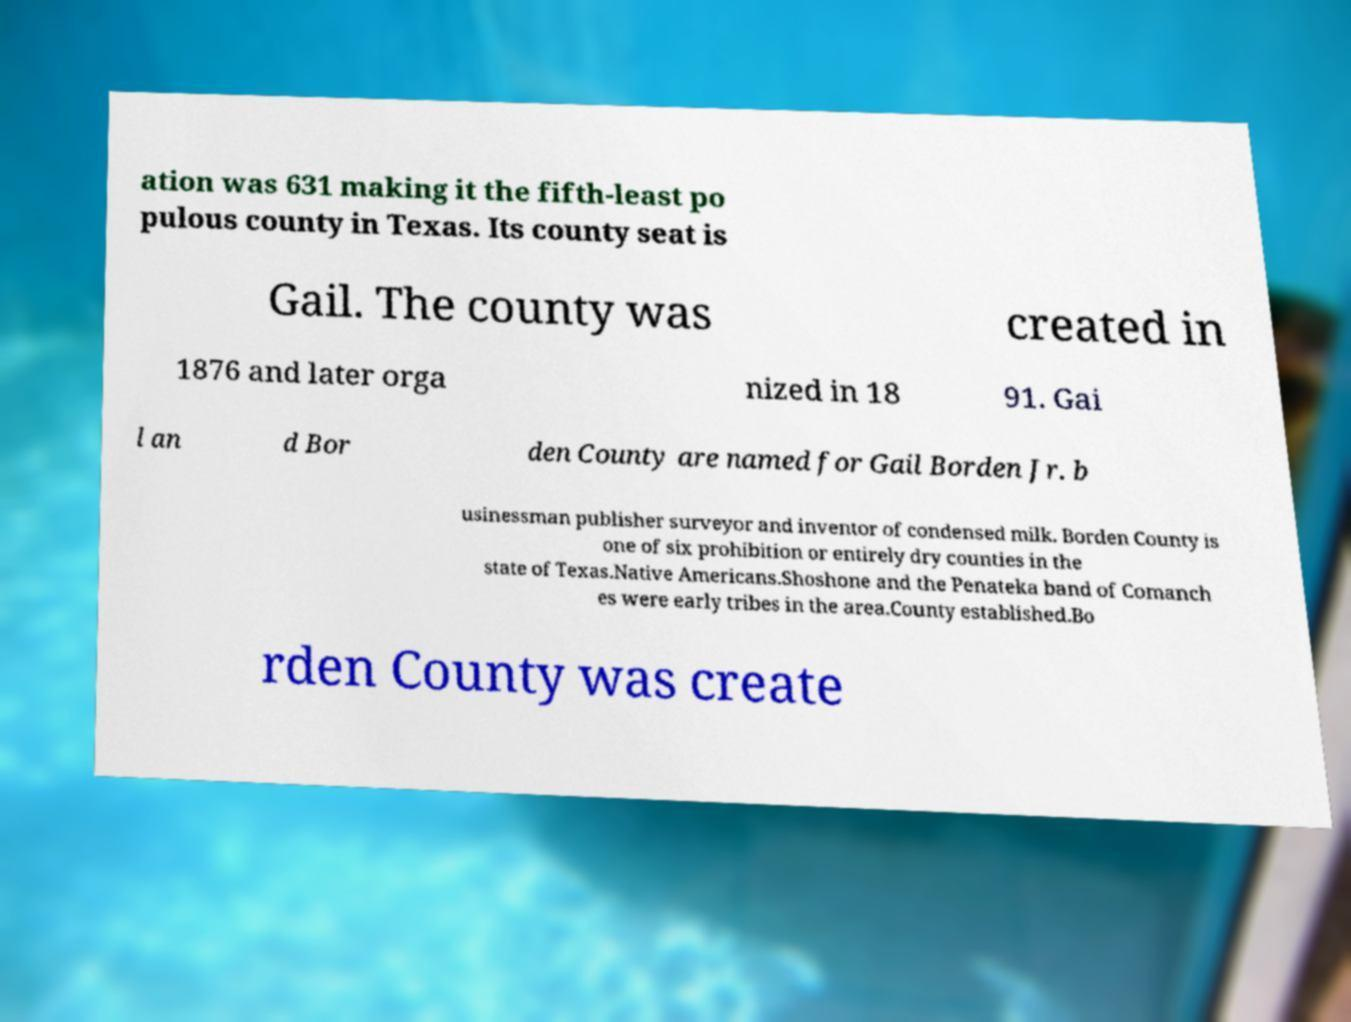Can you accurately transcribe the text from the provided image for me? ation was 631 making it the fifth-least po pulous county in Texas. Its county seat is Gail. The county was created in 1876 and later orga nized in 18 91. Gai l an d Bor den County are named for Gail Borden Jr. b usinessman publisher surveyor and inventor of condensed milk. Borden County is one of six prohibition or entirely dry counties in the state of Texas.Native Americans.Shoshone and the Penateka band of Comanch es were early tribes in the area.County established.Bo rden County was create 